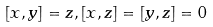<formula> <loc_0><loc_0><loc_500><loc_500>[ x , y ] = z , [ x , z ] = [ y , z ] = 0</formula> 